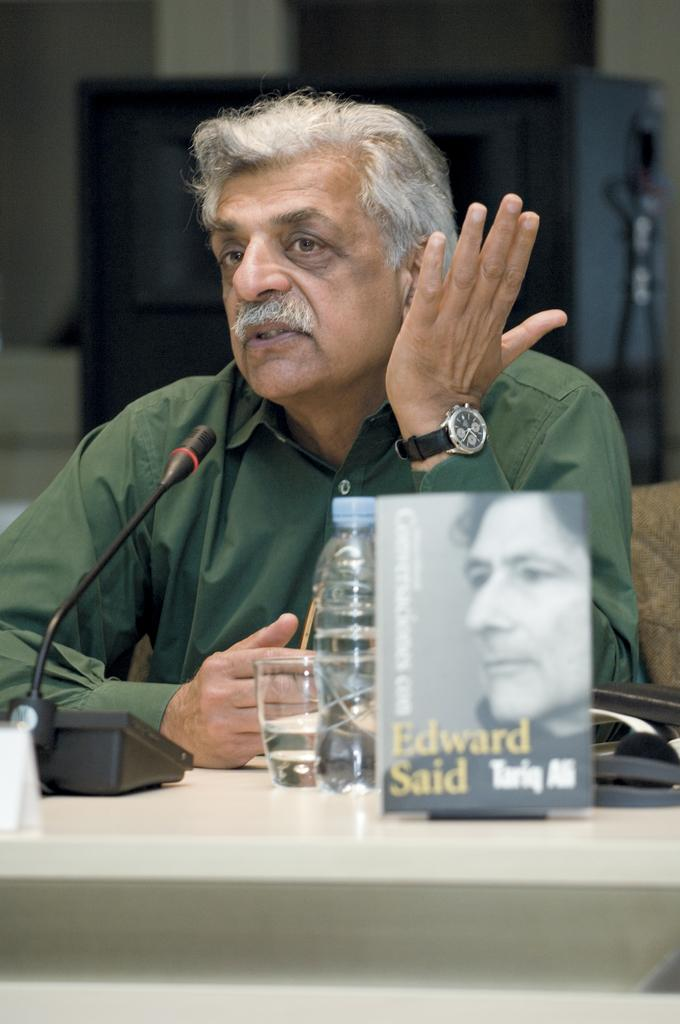What is the main subject of the image? The main subject of the image is a man. Can you describe the man's clothing? The man is wearing a green shirt. What is the man's hair color? The man has white hair. What is the man doing in the image? The man is sitting on a chair. Where is the chair located in relation to the table? The chair is in front of a table. What objects are on the table? There is a microphone (mike), a cup, a bottle, and a book on the table. How many ladybugs are crawling on the man's shirt in the image? There are no ladybugs present in the image. What type of degree does the man have, as indicated by the objects on the table? There is no indication of a degree in the image, as the objects on the table are a microphone, a cup, a bottle, and a book. 